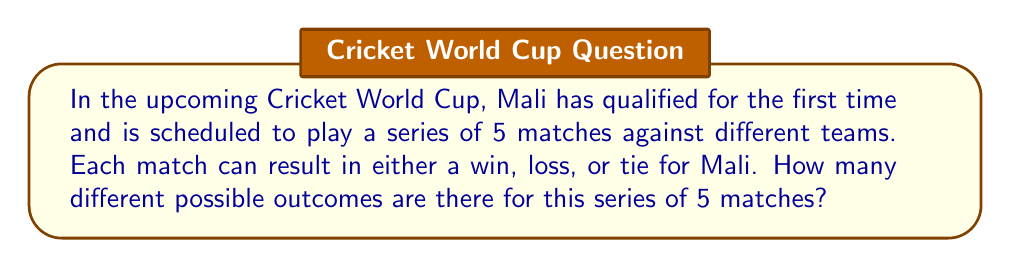Teach me how to tackle this problem. Let's approach this step-by-step:

1) For each match, there are 3 possible outcomes: win, loss, or tie.

2) We need to determine the number of ways these outcomes can occur over 5 matches.

3) This is a perfect scenario for using the multiplication principle in combinatorics.

4) The multiplication principle states that if we have $n$ independent events, and each event $i$ has $k_i$ possible outcomes, then the total number of possible outcomes for all events is the product of the number of outcomes for each event.

5) In this case, we have:
   - 5 independent events (the 5 matches)
   - Each event has 3 possible outcomes

6) Therefore, we can calculate the total number of possible outcomes as:

   $$ 3 \times 3 \times 3 \times 3 \times 3 = 3^5 $$

7) Let's compute this:
   $$ 3^5 = 3 \times 3 \times 3 \times 3 \times 3 = 243 $$

Thus, there are 243 different possible outcomes for Mali's 5-match series.
Answer: $243$ 